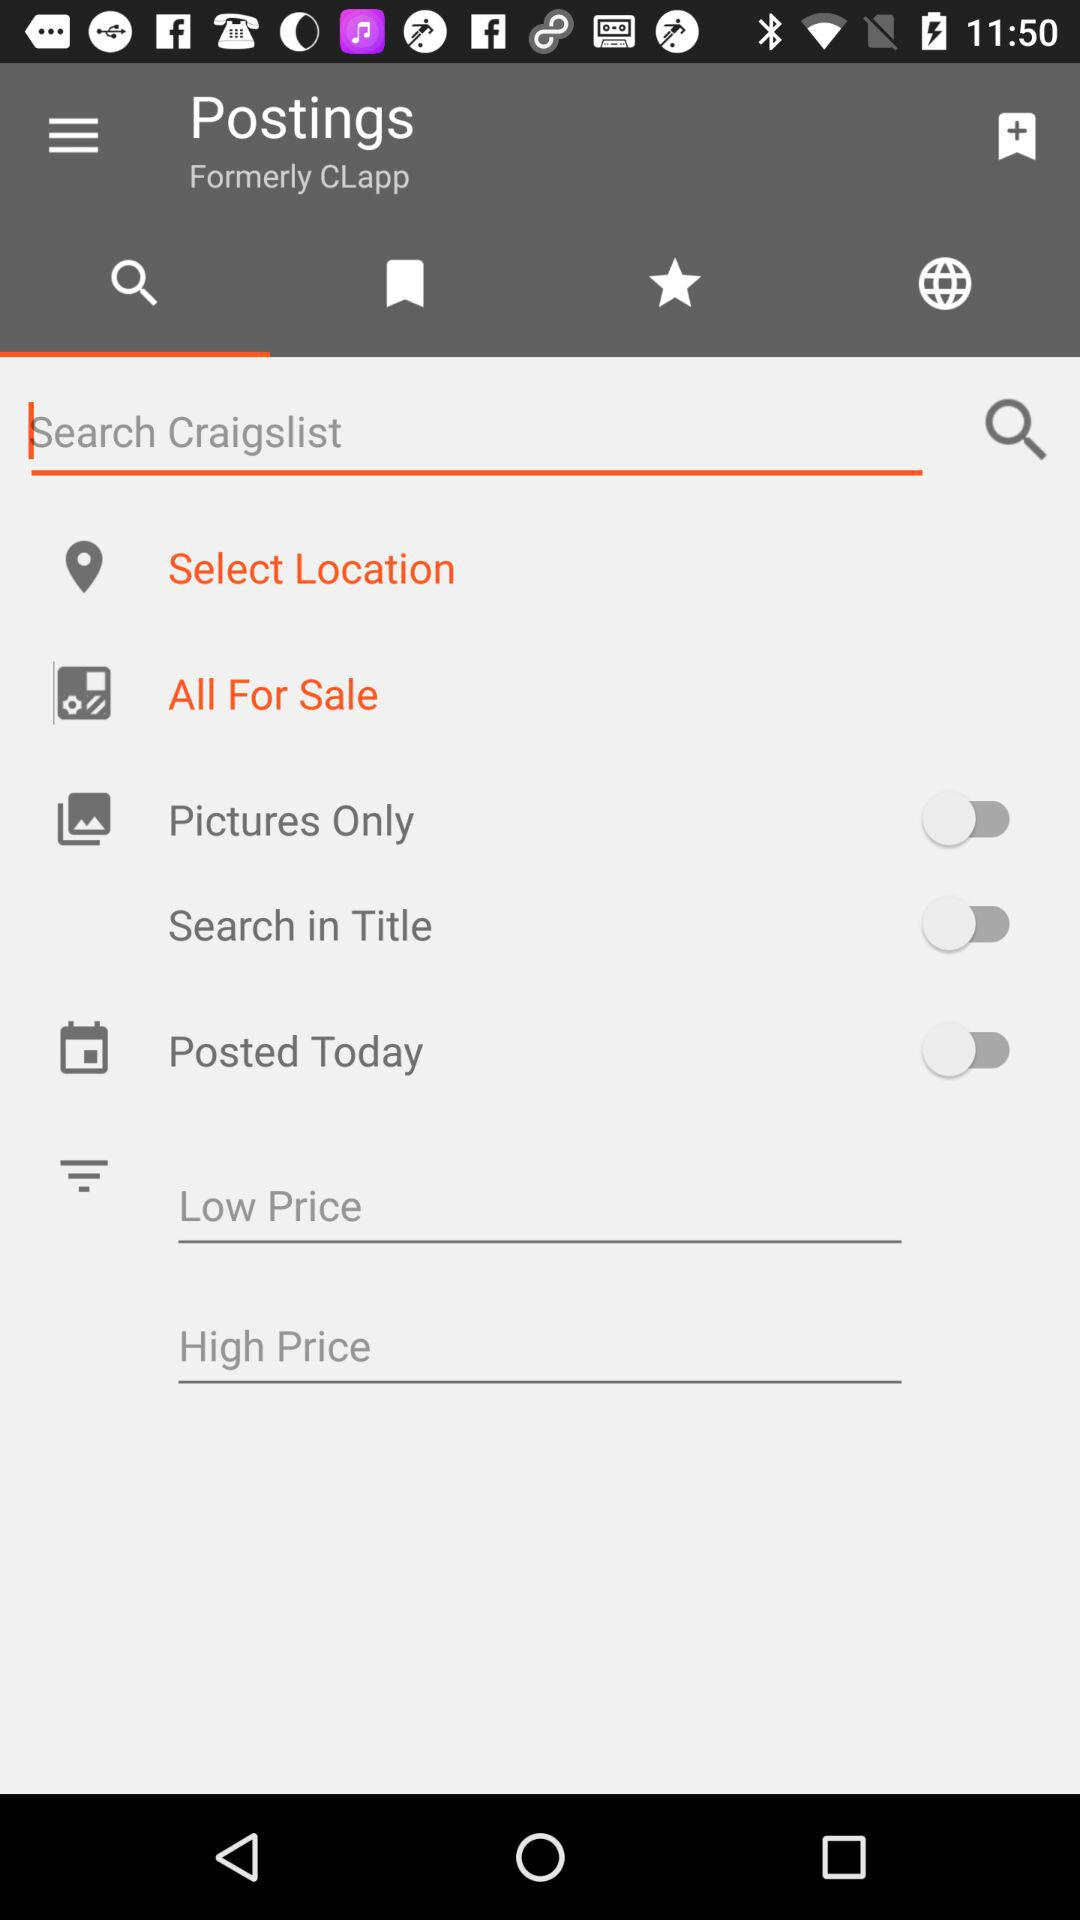How many price range items are there?
Answer the question using a single word or phrase. 2 